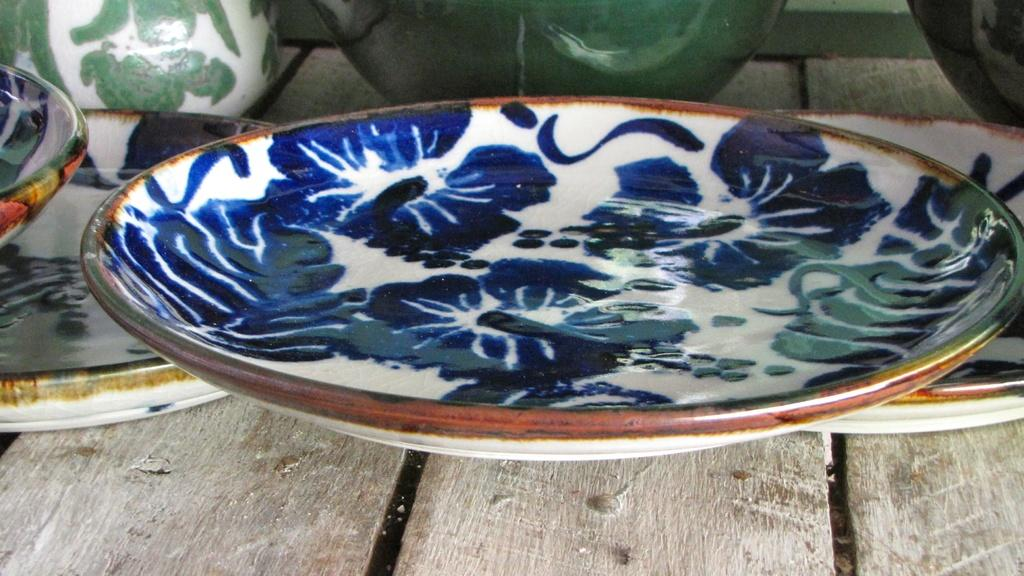What objects can be seen in the image? There are plates in the image. What can be observed about the appearance of the plates? There are designs on the plates. What type of disease is depicted on the plates in the image? There is no disease depicted on the plates in the image; they have designs on them. How does the rake help in the cultivation of the earth in the image? There is no rake or cultivation of the earth present in the image; it only features plates with designs on them. 